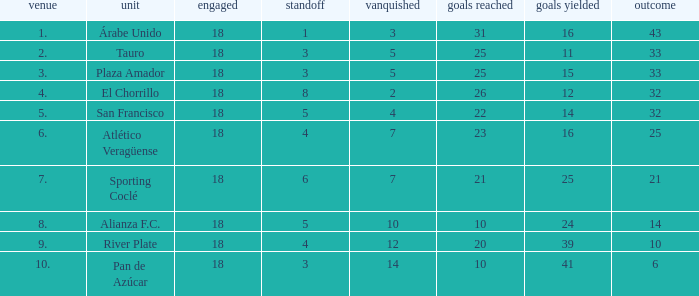How many goals were conceded by the team with more than 21 points more than 5 draws and less than 18 games played? None. 